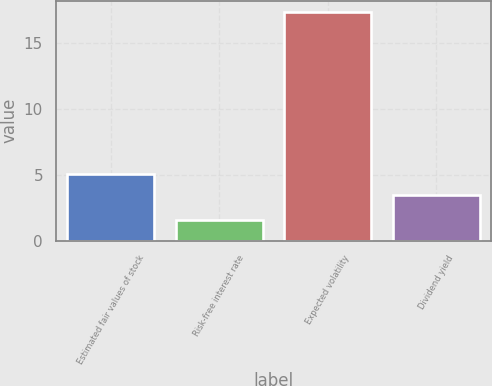<chart> <loc_0><loc_0><loc_500><loc_500><bar_chart><fcel>Estimated fair values of stock<fcel>Risk-free interest rate<fcel>Expected volatility<fcel>Dividend yield<nl><fcel>5.07<fcel>1.6<fcel>17.3<fcel>3.5<nl></chart> 